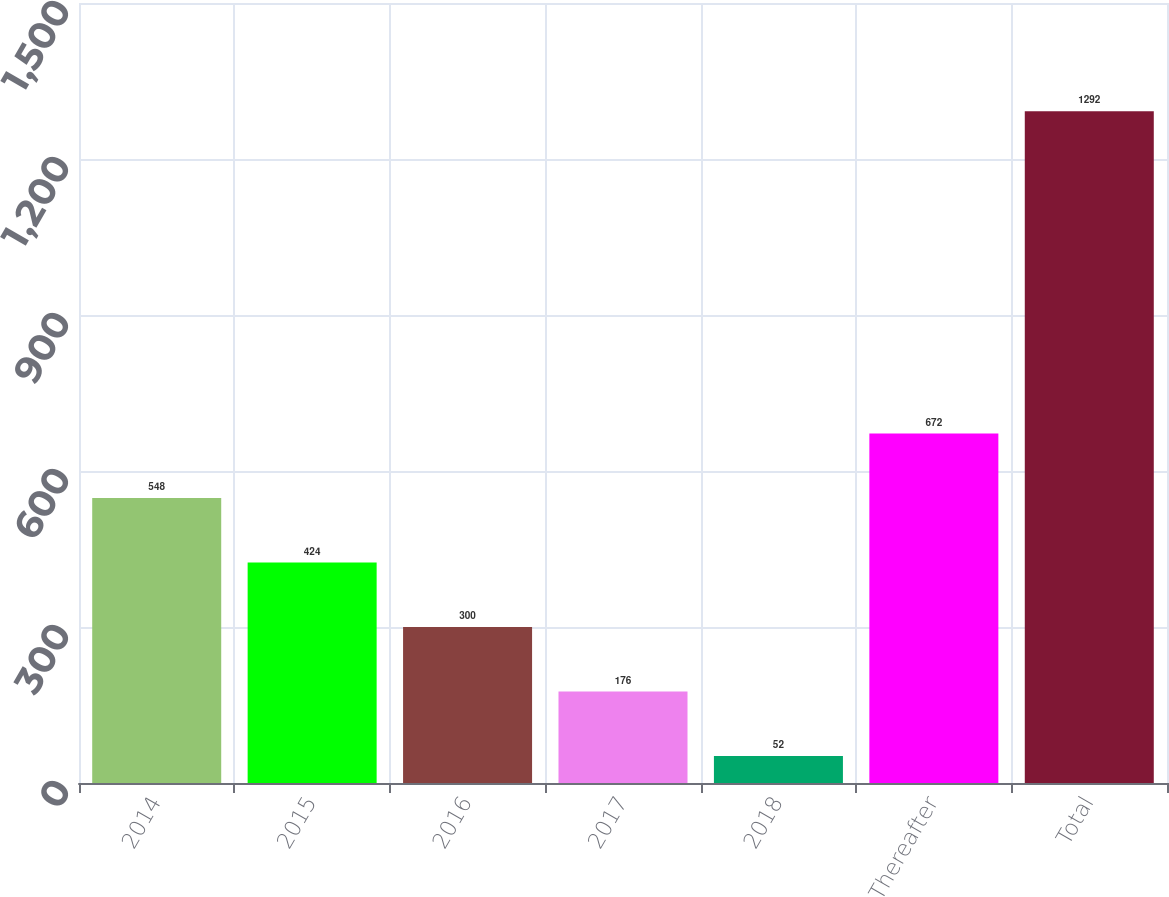Convert chart. <chart><loc_0><loc_0><loc_500><loc_500><bar_chart><fcel>2014<fcel>2015<fcel>2016<fcel>2017<fcel>2018<fcel>Thereafter<fcel>Total<nl><fcel>548<fcel>424<fcel>300<fcel>176<fcel>52<fcel>672<fcel>1292<nl></chart> 